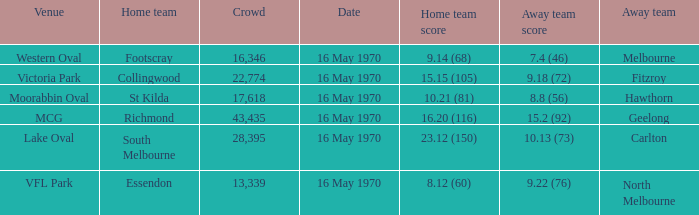What did the away team score when the home team was south melbourne? 10.13 (73). 